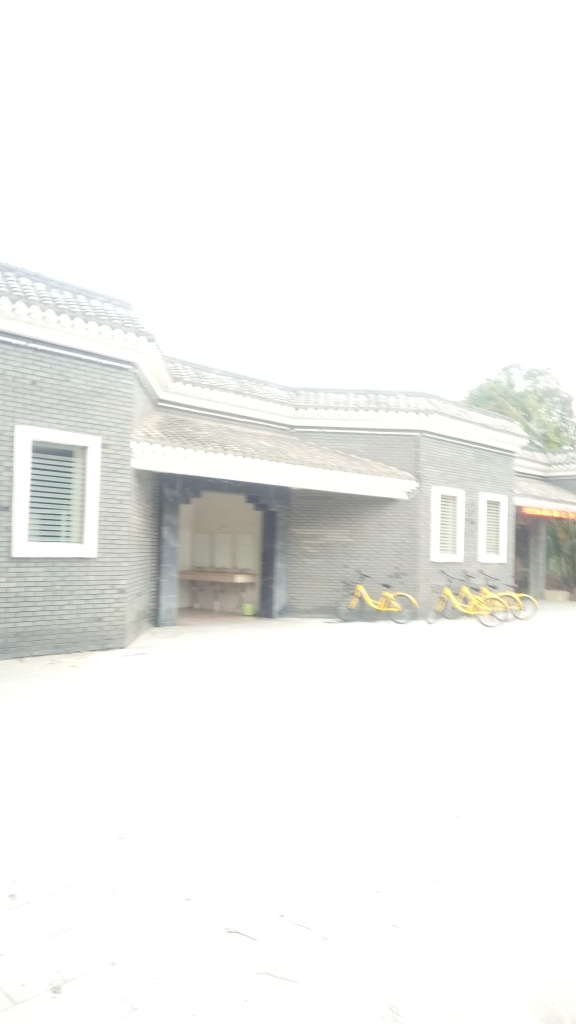Could you tell me more about the bicycles in front of the building? Certainly! There are yellow bicycles lined up in front of the building. They seem to be uniform in design, suggesting that they could be part of a bike-sharing program. Such initiatives are commonly found in urban and residential areas to promote eco-friendly transportation. 